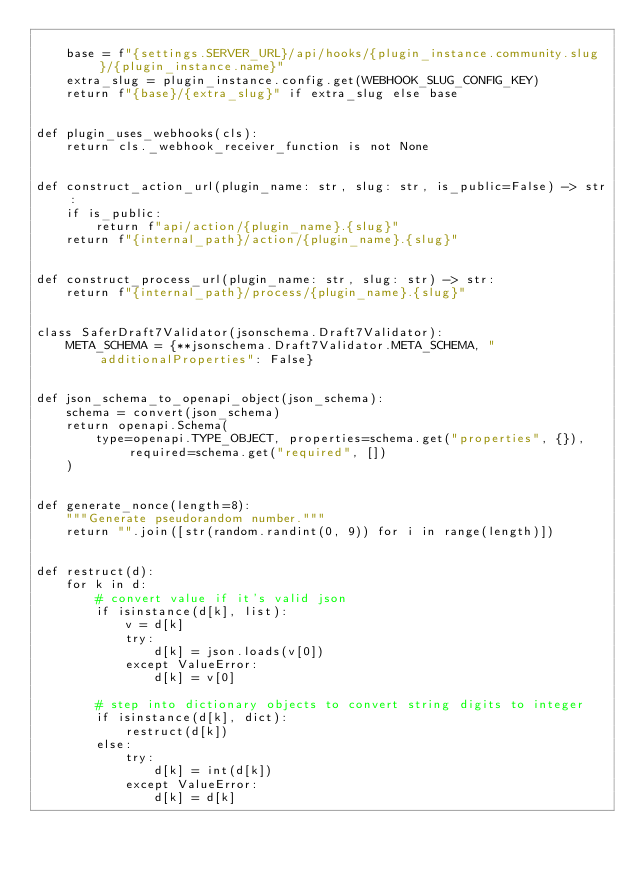Convert code to text. <code><loc_0><loc_0><loc_500><loc_500><_Python_>
    base = f"{settings.SERVER_URL}/api/hooks/{plugin_instance.community.slug}/{plugin_instance.name}"
    extra_slug = plugin_instance.config.get(WEBHOOK_SLUG_CONFIG_KEY)
    return f"{base}/{extra_slug}" if extra_slug else base


def plugin_uses_webhooks(cls):
    return cls._webhook_receiver_function is not None


def construct_action_url(plugin_name: str, slug: str, is_public=False) -> str:
    if is_public:
        return f"api/action/{plugin_name}.{slug}"
    return f"{internal_path}/action/{plugin_name}.{slug}"


def construct_process_url(plugin_name: str, slug: str) -> str:
    return f"{internal_path}/process/{plugin_name}.{slug}"


class SaferDraft7Validator(jsonschema.Draft7Validator):
    META_SCHEMA = {**jsonschema.Draft7Validator.META_SCHEMA, "additionalProperties": False}


def json_schema_to_openapi_object(json_schema):
    schema = convert(json_schema)
    return openapi.Schema(
        type=openapi.TYPE_OBJECT, properties=schema.get("properties", {}), required=schema.get("required", [])
    )


def generate_nonce(length=8):
    """Generate pseudorandom number."""
    return "".join([str(random.randint(0, 9)) for i in range(length)])


def restruct(d):
    for k in d:
        # convert value if it's valid json
        if isinstance(d[k], list):
            v = d[k]
            try:
                d[k] = json.loads(v[0])
            except ValueError:
                d[k] = v[0]

        # step into dictionary objects to convert string digits to integer
        if isinstance(d[k], dict):
            restruct(d[k])
        else:
            try:
                d[k] = int(d[k])
            except ValueError:
                d[k] = d[k]

</code> 